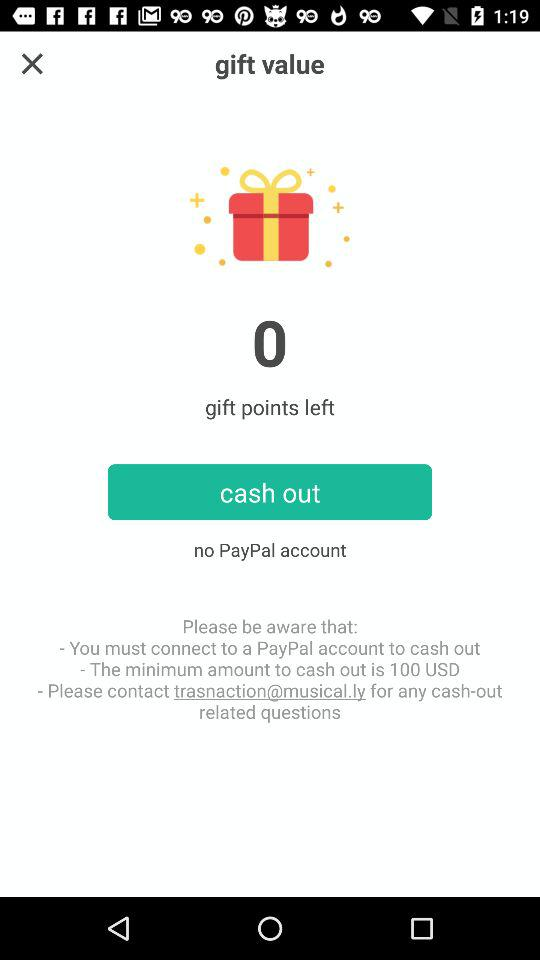How much is the minimum amount I can cash out?
Answer the question using a single word or phrase. 100 USD 